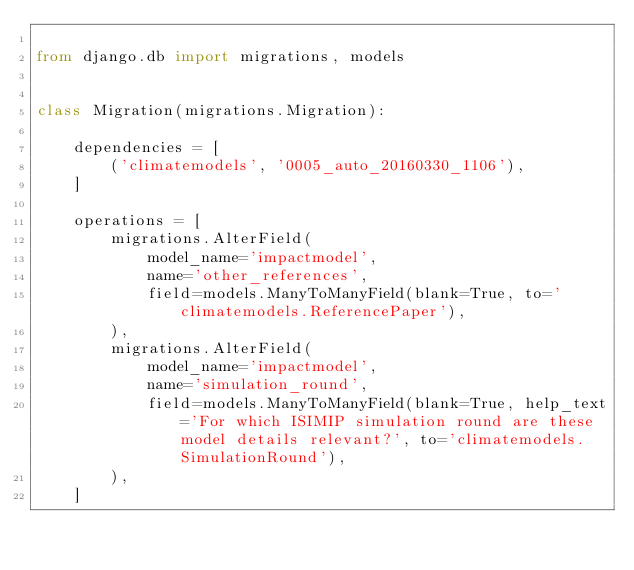Convert code to text. <code><loc_0><loc_0><loc_500><loc_500><_Python_>
from django.db import migrations, models


class Migration(migrations.Migration):

    dependencies = [
        ('climatemodels', '0005_auto_20160330_1106'),
    ]

    operations = [
        migrations.AlterField(
            model_name='impactmodel',
            name='other_references',
            field=models.ManyToManyField(blank=True, to='climatemodels.ReferencePaper'),
        ),
        migrations.AlterField(
            model_name='impactmodel',
            name='simulation_round',
            field=models.ManyToManyField(blank=True, help_text='For which ISIMIP simulation round are these model details relevant?', to='climatemodels.SimulationRound'),
        ),
    ]
</code> 